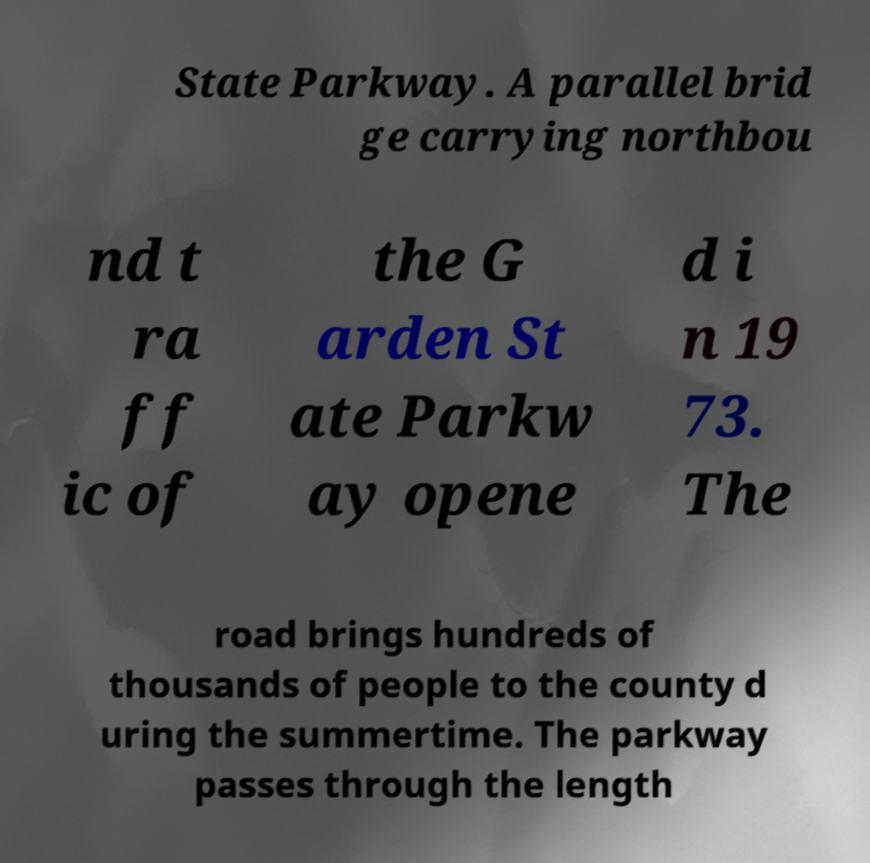Can you read and provide the text displayed in the image?This photo seems to have some interesting text. Can you extract and type it out for me? State Parkway. A parallel brid ge carrying northbou nd t ra ff ic of the G arden St ate Parkw ay opene d i n 19 73. The road brings hundreds of thousands of people to the county d uring the summertime. The parkway passes through the length 